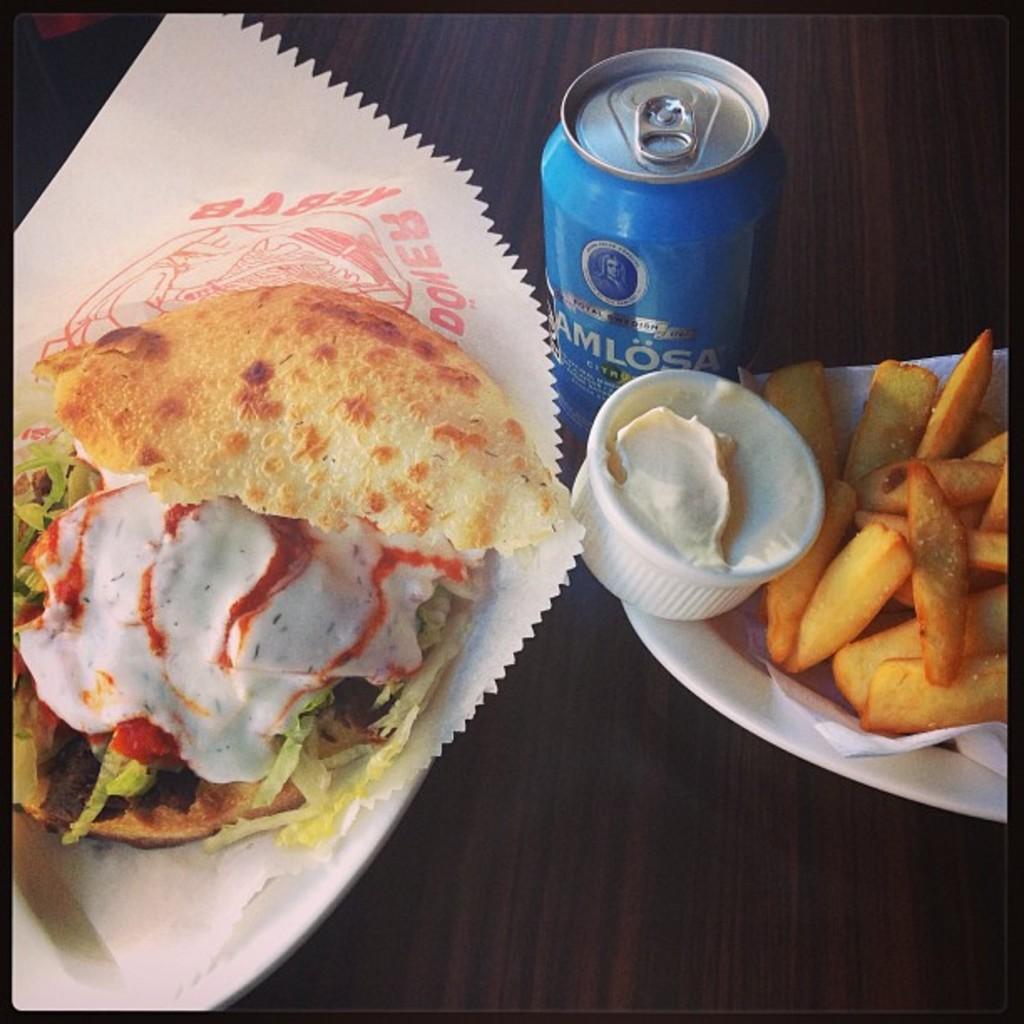Can you describe this image briefly? In this picture I can see there are a burger and fries placed on the plate and there is a beverage can place on the table. 